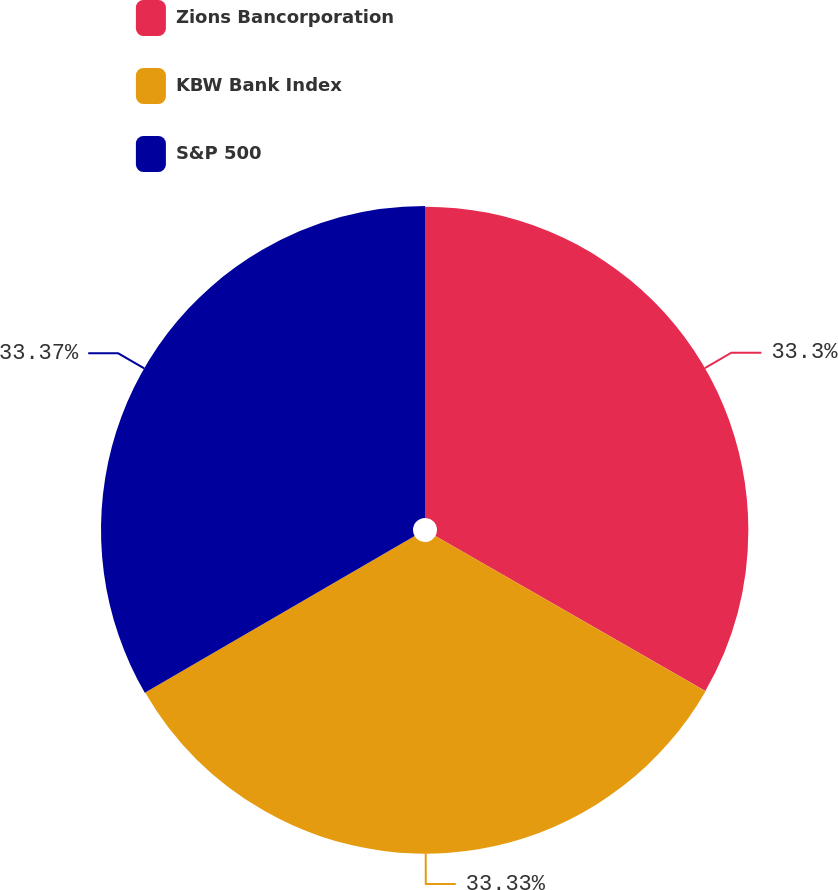Convert chart to OTSL. <chart><loc_0><loc_0><loc_500><loc_500><pie_chart><fcel>Zions Bancorporation<fcel>KBW Bank Index<fcel>S&P 500<nl><fcel>33.3%<fcel>33.33%<fcel>33.37%<nl></chart> 